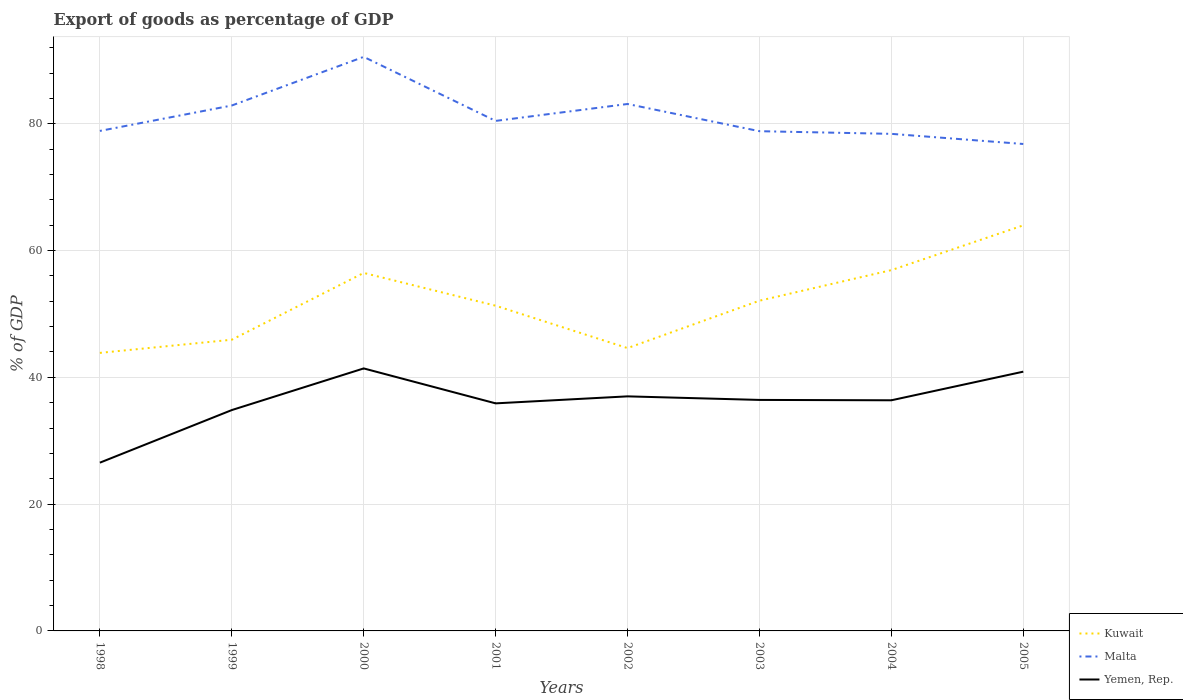Is the number of lines equal to the number of legend labels?
Give a very brief answer. Yes. Across all years, what is the maximum export of goods as percentage of GDP in Yemen, Rep.?
Your response must be concise. 26.54. In which year was the export of goods as percentage of GDP in Kuwait maximum?
Your response must be concise. 1998. What is the total export of goods as percentage of GDP in Malta in the graph?
Ensure brevity in your answer.  7.43. What is the difference between the highest and the second highest export of goods as percentage of GDP in Kuwait?
Provide a short and direct response. 20.12. How many lines are there?
Your answer should be very brief. 3. How many years are there in the graph?
Your answer should be very brief. 8. What is the difference between two consecutive major ticks on the Y-axis?
Provide a succinct answer. 20. Are the values on the major ticks of Y-axis written in scientific E-notation?
Give a very brief answer. No. Does the graph contain any zero values?
Provide a short and direct response. No. Does the graph contain grids?
Make the answer very short. Yes. Where does the legend appear in the graph?
Your answer should be very brief. Bottom right. How many legend labels are there?
Provide a succinct answer. 3. What is the title of the graph?
Make the answer very short. Export of goods as percentage of GDP. What is the label or title of the X-axis?
Your response must be concise. Years. What is the label or title of the Y-axis?
Your answer should be very brief. % of GDP. What is the % of GDP in Kuwait in 1998?
Ensure brevity in your answer.  43.86. What is the % of GDP of Malta in 1998?
Provide a succinct answer. 78.88. What is the % of GDP in Yemen, Rep. in 1998?
Give a very brief answer. 26.54. What is the % of GDP of Kuwait in 1999?
Provide a short and direct response. 45.94. What is the % of GDP in Malta in 1999?
Provide a succinct answer. 82.88. What is the % of GDP in Yemen, Rep. in 1999?
Give a very brief answer. 34.84. What is the % of GDP in Kuwait in 2000?
Your answer should be compact. 56.47. What is the % of GDP in Malta in 2000?
Give a very brief answer. 90.56. What is the % of GDP in Yemen, Rep. in 2000?
Make the answer very short. 41.41. What is the % of GDP of Kuwait in 2001?
Your answer should be very brief. 51.3. What is the % of GDP of Malta in 2001?
Give a very brief answer. 80.45. What is the % of GDP in Yemen, Rep. in 2001?
Give a very brief answer. 35.9. What is the % of GDP in Kuwait in 2002?
Your answer should be compact. 44.62. What is the % of GDP in Malta in 2002?
Your answer should be compact. 83.12. What is the % of GDP of Yemen, Rep. in 2002?
Make the answer very short. 37. What is the % of GDP of Kuwait in 2003?
Offer a very short reply. 52.09. What is the % of GDP of Malta in 2003?
Your answer should be very brief. 78.83. What is the % of GDP in Yemen, Rep. in 2003?
Offer a terse response. 36.44. What is the % of GDP in Kuwait in 2004?
Offer a terse response. 56.92. What is the % of GDP in Malta in 2004?
Provide a succinct answer. 78.41. What is the % of GDP of Yemen, Rep. in 2004?
Offer a terse response. 36.38. What is the % of GDP in Kuwait in 2005?
Keep it short and to the point. 63.98. What is the % of GDP of Malta in 2005?
Give a very brief answer. 76.81. What is the % of GDP of Yemen, Rep. in 2005?
Make the answer very short. 40.9. Across all years, what is the maximum % of GDP of Kuwait?
Offer a very short reply. 63.98. Across all years, what is the maximum % of GDP of Malta?
Provide a short and direct response. 90.56. Across all years, what is the maximum % of GDP in Yemen, Rep.?
Offer a terse response. 41.41. Across all years, what is the minimum % of GDP of Kuwait?
Give a very brief answer. 43.86. Across all years, what is the minimum % of GDP in Malta?
Offer a terse response. 76.81. Across all years, what is the minimum % of GDP in Yemen, Rep.?
Keep it short and to the point. 26.54. What is the total % of GDP of Kuwait in the graph?
Make the answer very short. 415.17. What is the total % of GDP in Malta in the graph?
Offer a terse response. 649.95. What is the total % of GDP in Yemen, Rep. in the graph?
Provide a short and direct response. 289.41. What is the difference between the % of GDP in Kuwait in 1998 and that in 1999?
Provide a short and direct response. -2.08. What is the difference between the % of GDP in Malta in 1998 and that in 1999?
Your answer should be compact. -4.01. What is the difference between the % of GDP of Yemen, Rep. in 1998 and that in 1999?
Provide a short and direct response. -8.3. What is the difference between the % of GDP in Kuwait in 1998 and that in 2000?
Keep it short and to the point. -12.61. What is the difference between the % of GDP of Malta in 1998 and that in 2000?
Provide a succinct answer. -11.68. What is the difference between the % of GDP in Yemen, Rep. in 1998 and that in 2000?
Offer a terse response. -14.87. What is the difference between the % of GDP of Kuwait in 1998 and that in 2001?
Make the answer very short. -7.44. What is the difference between the % of GDP of Malta in 1998 and that in 2001?
Provide a succinct answer. -1.58. What is the difference between the % of GDP in Yemen, Rep. in 1998 and that in 2001?
Provide a short and direct response. -9.35. What is the difference between the % of GDP of Kuwait in 1998 and that in 2002?
Give a very brief answer. -0.76. What is the difference between the % of GDP in Malta in 1998 and that in 2002?
Make the answer very short. -4.25. What is the difference between the % of GDP in Yemen, Rep. in 1998 and that in 2002?
Ensure brevity in your answer.  -10.46. What is the difference between the % of GDP of Kuwait in 1998 and that in 2003?
Make the answer very short. -8.23. What is the difference between the % of GDP of Malta in 1998 and that in 2003?
Your response must be concise. 0.04. What is the difference between the % of GDP in Yemen, Rep. in 1998 and that in 2003?
Offer a terse response. -9.9. What is the difference between the % of GDP of Kuwait in 1998 and that in 2004?
Keep it short and to the point. -13.06. What is the difference between the % of GDP in Malta in 1998 and that in 2004?
Ensure brevity in your answer.  0.46. What is the difference between the % of GDP of Yemen, Rep. in 1998 and that in 2004?
Keep it short and to the point. -9.84. What is the difference between the % of GDP in Kuwait in 1998 and that in 2005?
Ensure brevity in your answer.  -20.12. What is the difference between the % of GDP in Malta in 1998 and that in 2005?
Provide a succinct answer. 2.06. What is the difference between the % of GDP in Yemen, Rep. in 1998 and that in 2005?
Your answer should be compact. -14.35. What is the difference between the % of GDP of Kuwait in 1999 and that in 2000?
Your answer should be compact. -10.54. What is the difference between the % of GDP in Malta in 1999 and that in 2000?
Ensure brevity in your answer.  -7.67. What is the difference between the % of GDP in Yemen, Rep. in 1999 and that in 2000?
Your answer should be compact. -6.57. What is the difference between the % of GDP of Kuwait in 1999 and that in 2001?
Provide a short and direct response. -5.37. What is the difference between the % of GDP of Malta in 1999 and that in 2001?
Ensure brevity in your answer.  2.43. What is the difference between the % of GDP of Yemen, Rep. in 1999 and that in 2001?
Your answer should be very brief. -1.06. What is the difference between the % of GDP of Kuwait in 1999 and that in 2002?
Provide a succinct answer. 1.32. What is the difference between the % of GDP of Malta in 1999 and that in 2002?
Your answer should be very brief. -0.24. What is the difference between the % of GDP in Yemen, Rep. in 1999 and that in 2002?
Keep it short and to the point. -2.16. What is the difference between the % of GDP of Kuwait in 1999 and that in 2003?
Your answer should be very brief. -6.16. What is the difference between the % of GDP of Malta in 1999 and that in 2003?
Keep it short and to the point. 4.05. What is the difference between the % of GDP in Yemen, Rep. in 1999 and that in 2003?
Offer a very short reply. -1.6. What is the difference between the % of GDP of Kuwait in 1999 and that in 2004?
Offer a terse response. -10.98. What is the difference between the % of GDP of Malta in 1999 and that in 2004?
Give a very brief answer. 4.47. What is the difference between the % of GDP of Yemen, Rep. in 1999 and that in 2004?
Make the answer very short. -1.54. What is the difference between the % of GDP of Kuwait in 1999 and that in 2005?
Offer a terse response. -18.04. What is the difference between the % of GDP of Malta in 1999 and that in 2005?
Ensure brevity in your answer.  6.07. What is the difference between the % of GDP of Yemen, Rep. in 1999 and that in 2005?
Provide a succinct answer. -6.06. What is the difference between the % of GDP in Kuwait in 2000 and that in 2001?
Your answer should be very brief. 5.17. What is the difference between the % of GDP in Malta in 2000 and that in 2001?
Provide a succinct answer. 10.1. What is the difference between the % of GDP of Yemen, Rep. in 2000 and that in 2001?
Your response must be concise. 5.51. What is the difference between the % of GDP in Kuwait in 2000 and that in 2002?
Provide a succinct answer. 11.86. What is the difference between the % of GDP in Malta in 2000 and that in 2002?
Offer a very short reply. 7.43. What is the difference between the % of GDP of Yemen, Rep. in 2000 and that in 2002?
Make the answer very short. 4.41. What is the difference between the % of GDP in Kuwait in 2000 and that in 2003?
Your answer should be compact. 4.38. What is the difference between the % of GDP of Malta in 2000 and that in 2003?
Give a very brief answer. 11.73. What is the difference between the % of GDP in Yemen, Rep. in 2000 and that in 2003?
Ensure brevity in your answer.  4.97. What is the difference between the % of GDP in Kuwait in 2000 and that in 2004?
Offer a terse response. -0.44. What is the difference between the % of GDP of Malta in 2000 and that in 2004?
Ensure brevity in your answer.  12.14. What is the difference between the % of GDP in Yemen, Rep. in 2000 and that in 2004?
Keep it short and to the point. 5.03. What is the difference between the % of GDP in Kuwait in 2000 and that in 2005?
Make the answer very short. -7.5. What is the difference between the % of GDP in Malta in 2000 and that in 2005?
Your answer should be very brief. 13.74. What is the difference between the % of GDP in Yemen, Rep. in 2000 and that in 2005?
Make the answer very short. 0.51. What is the difference between the % of GDP of Kuwait in 2001 and that in 2002?
Provide a succinct answer. 6.69. What is the difference between the % of GDP of Malta in 2001 and that in 2002?
Your answer should be compact. -2.67. What is the difference between the % of GDP in Yemen, Rep. in 2001 and that in 2002?
Provide a short and direct response. -1.1. What is the difference between the % of GDP in Kuwait in 2001 and that in 2003?
Offer a terse response. -0.79. What is the difference between the % of GDP of Malta in 2001 and that in 2003?
Provide a succinct answer. 1.62. What is the difference between the % of GDP of Yemen, Rep. in 2001 and that in 2003?
Give a very brief answer. -0.54. What is the difference between the % of GDP in Kuwait in 2001 and that in 2004?
Keep it short and to the point. -5.61. What is the difference between the % of GDP of Malta in 2001 and that in 2004?
Your response must be concise. 2.04. What is the difference between the % of GDP of Yemen, Rep. in 2001 and that in 2004?
Make the answer very short. -0.49. What is the difference between the % of GDP of Kuwait in 2001 and that in 2005?
Offer a terse response. -12.67. What is the difference between the % of GDP of Malta in 2001 and that in 2005?
Your response must be concise. 3.64. What is the difference between the % of GDP of Yemen, Rep. in 2001 and that in 2005?
Keep it short and to the point. -5. What is the difference between the % of GDP of Kuwait in 2002 and that in 2003?
Offer a very short reply. -7.48. What is the difference between the % of GDP of Malta in 2002 and that in 2003?
Ensure brevity in your answer.  4.29. What is the difference between the % of GDP of Yemen, Rep. in 2002 and that in 2003?
Offer a very short reply. 0.56. What is the difference between the % of GDP in Kuwait in 2002 and that in 2004?
Ensure brevity in your answer.  -12.3. What is the difference between the % of GDP of Malta in 2002 and that in 2004?
Keep it short and to the point. 4.71. What is the difference between the % of GDP in Yemen, Rep. in 2002 and that in 2004?
Keep it short and to the point. 0.62. What is the difference between the % of GDP of Kuwait in 2002 and that in 2005?
Ensure brevity in your answer.  -19.36. What is the difference between the % of GDP in Malta in 2002 and that in 2005?
Make the answer very short. 6.31. What is the difference between the % of GDP of Yemen, Rep. in 2002 and that in 2005?
Ensure brevity in your answer.  -3.9. What is the difference between the % of GDP in Kuwait in 2003 and that in 2004?
Your answer should be compact. -4.82. What is the difference between the % of GDP in Malta in 2003 and that in 2004?
Your response must be concise. 0.42. What is the difference between the % of GDP in Yemen, Rep. in 2003 and that in 2004?
Your answer should be very brief. 0.06. What is the difference between the % of GDP in Kuwait in 2003 and that in 2005?
Your response must be concise. -11.88. What is the difference between the % of GDP in Malta in 2003 and that in 2005?
Your response must be concise. 2.02. What is the difference between the % of GDP of Yemen, Rep. in 2003 and that in 2005?
Offer a terse response. -4.46. What is the difference between the % of GDP in Kuwait in 2004 and that in 2005?
Offer a terse response. -7.06. What is the difference between the % of GDP in Malta in 2004 and that in 2005?
Your response must be concise. 1.6. What is the difference between the % of GDP in Yemen, Rep. in 2004 and that in 2005?
Offer a very short reply. -4.51. What is the difference between the % of GDP in Kuwait in 1998 and the % of GDP in Malta in 1999?
Your answer should be compact. -39.03. What is the difference between the % of GDP in Kuwait in 1998 and the % of GDP in Yemen, Rep. in 1999?
Offer a terse response. 9.02. What is the difference between the % of GDP of Malta in 1998 and the % of GDP of Yemen, Rep. in 1999?
Offer a terse response. 44.04. What is the difference between the % of GDP of Kuwait in 1998 and the % of GDP of Malta in 2000?
Provide a short and direct response. -46.7. What is the difference between the % of GDP of Kuwait in 1998 and the % of GDP of Yemen, Rep. in 2000?
Your answer should be compact. 2.45. What is the difference between the % of GDP of Malta in 1998 and the % of GDP of Yemen, Rep. in 2000?
Your answer should be very brief. 37.47. What is the difference between the % of GDP in Kuwait in 1998 and the % of GDP in Malta in 2001?
Make the answer very short. -36.6. What is the difference between the % of GDP in Kuwait in 1998 and the % of GDP in Yemen, Rep. in 2001?
Make the answer very short. 7.96. What is the difference between the % of GDP of Malta in 1998 and the % of GDP of Yemen, Rep. in 2001?
Your response must be concise. 42.98. What is the difference between the % of GDP of Kuwait in 1998 and the % of GDP of Malta in 2002?
Keep it short and to the point. -39.26. What is the difference between the % of GDP in Kuwait in 1998 and the % of GDP in Yemen, Rep. in 2002?
Offer a very short reply. 6.86. What is the difference between the % of GDP of Malta in 1998 and the % of GDP of Yemen, Rep. in 2002?
Offer a terse response. 41.87. What is the difference between the % of GDP in Kuwait in 1998 and the % of GDP in Malta in 2003?
Your response must be concise. -34.97. What is the difference between the % of GDP of Kuwait in 1998 and the % of GDP of Yemen, Rep. in 2003?
Provide a succinct answer. 7.42. What is the difference between the % of GDP of Malta in 1998 and the % of GDP of Yemen, Rep. in 2003?
Give a very brief answer. 42.44. What is the difference between the % of GDP of Kuwait in 1998 and the % of GDP of Malta in 2004?
Offer a very short reply. -34.55. What is the difference between the % of GDP of Kuwait in 1998 and the % of GDP of Yemen, Rep. in 2004?
Offer a terse response. 7.48. What is the difference between the % of GDP in Malta in 1998 and the % of GDP in Yemen, Rep. in 2004?
Your answer should be compact. 42.49. What is the difference between the % of GDP in Kuwait in 1998 and the % of GDP in Malta in 2005?
Give a very brief answer. -32.95. What is the difference between the % of GDP of Kuwait in 1998 and the % of GDP of Yemen, Rep. in 2005?
Offer a terse response. 2.96. What is the difference between the % of GDP in Malta in 1998 and the % of GDP in Yemen, Rep. in 2005?
Ensure brevity in your answer.  37.98. What is the difference between the % of GDP in Kuwait in 1999 and the % of GDP in Malta in 2000?
Your answer should be compact. -44.62. What is the difference between the % of GDP of Kuwait in 1999 and the % of GDP of Yemen, Rep. in 2000?
Provide a short and direct response. 4.53. What is the difference between the % of GDP in Malta in 1999 and the % of GDP in Yemen, Rep. in 2000?
Offer a terse response. 41.48. What is the difference between the % of GDP in Kuwait in 1999 and the % of GDP in Malta in 2001?
Your response must be concise. -34.52. What is the difference between the % of GDP of Kuwait in 1999 and the % of GDP of Yemen, Rep. in 2001?
Provide a succinct answer. 10.04. What is the difference between the % of GDP of Malta in 1999 and the % of GDP of Yemen, Rep. in 2001?
Ensure brevity in your answer.  46.99. What is the difference between the % of GDP of Kuwait in 1999 and the % of GDP of Malta in 2002?
Your response must be concise. -37.19. What is the difference between the % of GDP of Kuwait in 1999 and the % of GDP of Yemen, Rep. in 2002?
Ensure brevity in your answer.  8.94. What is the difference between the % of GDP of Malta in 1999 and the % of GDP of Yemen, Rep. in 2002?
Offer a very short reply. 45.88. What is the difference between the % of GDP in Kuwait in 1999 and the % of GDP in Malta in 2003?
Give a very brief answer. -32.89. What is the difference between the % of GDP in Kuwait in 1999 and the % of GDP in Yemen, Rep. in 2003?
Your answer should be compact. 9.5. What is the difference between the % of GDP of Malta in 1999 and the % of GDP of Yemen, Rep. in 2003?
Your answer should be compact. 46.45. What is the difference between the % of GDP in Kuwait in 1999 and the % of GDP in Malta in 2004?
Make the answer very short. -32.48. What is the difference between the % of GDP in Kuwait in 1999 and the % of GDP in Yemen, Rep. in 2004?
Give a very brief answer. 9.55. What is the difference between the % of GDP in Malta in 1999 and the % of GDP in Yemen, Rep. in 2004?
Offer a very short reply. 46.5. What is the difference between the % of GDP in Kuwait in 1999 and the % of GDP in Malta in 2005?
Make the answer very short. -30.88. What is the difference between the % of GDP in Kuwait in 1999 and the % of GDP in Yemen, Rep. in 2005?
Provide a short and direct response. 5.04. What is the difference between the % of GDP in Malta in 1999 and the % of GDP in Yemen, Rep. in 2005?
Offer a terse response. 41.99. What is the difference between the % of GDP in Kuwait in 2000 and the % of GDP in Malta in 2001?
Your response must be concise. -23.98. What is the difference between the % of GDP in Kuwait in 2000 and the % of GDP in Yemen, Rep. in 2001?
Give a very brief answer. 20.58. What is the difference between the % of GDP in Malta in 2000 and the % of GDP in Yemen, Rep. in 2001?
Give a very brief answer. 54.66. What is the difference between the % of GDP in Kuwait in 2000 and the % of GDP in Malta in 2002?
Keep it short and to the point. -26.65. What is the difference between the % of GDP of Kuwait in 2000 and the % of GDP of Yemen, Rep. in 2002?
Your response must be concise. 19.47. What is the difference between the % of GDP in Malta in 2000 and the % of GDP in Yemen, Rep. in 2002?
Offer a terse response. 53.56. What is the difference between the % of GDP in Kuwait in 2000 and the % of GDP in Malta in 2003?
Offer a terse response. -22.36. What is the difference between the % of GDP of Kuwait in 2000 and the % of GDP of Yemen, Rep. in 2003?
Your answer should be compact. 20.03. What is the difference between the % of GDP of Malta in 2000 and the % of GDP of Yemen, Rep. in 2003?
Your answer should be compact. 54.12. What is the difference between the % of GDP in Kuwait in 2000 and the % of GDP in Malta in 2004?
Provide a short and direct response. -21.94. What is the difference between the % of GDP in Kuwait in 2000 and the % of GDP in Yemen, Rep. in 2004?
Offer a very short reply. 20.09. What is the difference between the % of GDP in Malta in 2000 and the % of GDP in Yemen, Rep. in 2004?
Provide a succinct answer. 54.17. What is the difference between the % of GDP in Kuwait in 2000 and the % of GDP in Malta in 2005?
Ensure brevity in your answer.  -20.34. What is the difference between the % of GDP in Kuwait in 2000 and the % of GDP in Yemen, Rep. in 2005?
Your answer should be compact. 15.58. What is the difference between the % of GDP of Malta in 2000 and the % of GDP of Yemen, Rep. in 2005?
Provide a short and direct response. 49.66. What is the difference between the % of GDP in Kuwait in 2001 and the % of GDP in Malta in 2002?
Offer a terse response. -31.82. What is the difference between the % of GDP of Kuwait in 2001 and the % of GDP of Yemen, Rep. in 2002?
Make the answer very short. 14.3. What is the difference between the % of GDP of Malta in 2001 and the % of GDP of Yemen, Rep. in 2002?
Your answer should be very brief. 43.45. What is the difference between the % of GDP in Kuwait in 2001 and the % of GDP in Malta in 2003?
Your answer should be compact. -27.53. What is the difference between the % of GDP in Kuwait in 2001 and the % of GDP in Yemen, Rep. in 2003?
Keep it short and to the point. 14.86. What is the difference between the % of GDP in Malta in 2001 and the % of GDP in Yemen, Rep. in 2003?
Your response must be concise. 44.02. What is the difference between the % of GDP of Kuwait in 2001 and the % of GDP of Malta in 2004?
Provide a succinct answer. -27.11. What is the difference between the % of GDP in Kuwait in 2001 and the % of GDP in Yemen, Rep. in 2004?
Provide a short and direct response. 14.92. What is the difference between the % of GDP of Malta in 2001 and the % of GDP of Yemen, Rep. in 2004?
Offer a very short reply. 44.07. What is the difference between the % of GDP in Kuwait in 2001 and the % of GDP in Malta in 2005?
Make the answer very short. -25.51. What is the difference between the % of GDP of Kuwait in 2001 and the % of GDP of Yemen, Rep. in 2005?
Give a very brief answer. 10.41. What is the difference between the % of GDP of Malta in 2001 and the % of GDP of Yemen, Rep. in 2005?
Provide a short and direct response. 39.56. What is the difference between the % of GDP of Kuwait in 2002 and the % of GDP of Malta in 2003?
Provide a short and direct response. -34.22. What is the difference between the % of GDP of Kuwait in 2002 and the % of GDP of Yemen, Rep. in 2003?
Give a very brief answer. 8.18. What is the difference between the % of GDP of Malta in 2002 and the % of GDP of Yemen, Rep. in 2003?
Give a very brief answer. 46.68. What is the difference between the % of GDP of Kuwait in 2002 and the % of GDP of Malta in 2004?
Offer a terse response. -33.8. What is the difference between the % of GDP of Kuwait in 2002 and the % of GDP of Yemen, Rep. in 2004?
Offer a very short reply. 8.23. What is the difference between the % of GDP in Malta in 2002 and the % of GDP in Yemen, Rep. in 2004?
Ensure brevity in your answer.  46.74. What is the difference between the % of GDP of Kuwait in 2002 and the % of GDP of Malta in 2005?
Your response must be concise. -32.2. What is the difference between the % of GDP of Kuwait in 2002 and the % of GDP of Yemen, Rep. in 2005?
Ensure brevity in your answer.  3.72. What is the difference between the % of GDP in Malta in 2002 and the % of GDP in Yemen, Rep. in 2005?
Provide a succinct answer. 42.23. What is the difference between the % of GDP in Kuwait in 2003 and the % of GDP in Malta in 2004?
Offer a very short reply. -26.32. What is the difference between the % of GDP in Kuwait in 2003 and the % of GDP in Yemen, Rep. in 2004?
Your response must be concise. 15.71. What is the difference between the % of GDP of Malta in 2003 and the % of GDP of Yemen, Rep. in 2004?
Provide a short and direct response. 42.45. What is the difference between the % of GDP of Kuwait in 2003 and the % of GDP of Malta in 2005?
Provide a short and direct response. -24.72. What is the difference between the % of GDP in Kuwait in 2003 and the % of GDP in Yemen, Rep. in 2005?
Make the answer very short. 11.2. What is the difference between the % of GDP of Malta in 2003 and the % of GDP of Yemen, Rep. in 2005?
Provide a short and direct response. 37.93. What is the difference between the % of GDP in Kuwait in 2004 and the % of GDP in Malta in 2005?
Give a very brief answer. -19.9. What is the difference between the % of GDP in Kuwait in 2004 and the % of GDP in Yemen, Rep. in 2005?
Your response must be concise. 16.02. What is the difference between the % of GDP in Malta in 2004 and the % of GDP in Yemen, Rep. in 2005?
Ensure brevity in your answer.  37.52. What is the average % of GDP in Kuwait per year?
Ensure brevity in your answer.  51.9. What is the average % of GDP in Malta per year?
Provide a succinct answer. 81.24. What is the average % of GDP of Yemen, Rep. per year?
Give a very brief answer. 36.18. In the year 1998, what is the difference between the % of GDP of Kuwait and % of GDP of Malta?
Provide a short and direct response. -35.02. In the year 1998, what is the difference between the % of GDP of Kuwait and % of GDP of Yemen, Rep.?
Offer a very short reply. 17.32. In the year 1998, what is the difference between the % of GDP of Malta and % of GDP of Yemen, Rep.?
Make the answer very short. 52.33. In the year 1999, what is the difference between the % of GDP in Kuwait and % of GDP in Malta?
Provide a succinct answer. -36.95. In the year 1999, what is the difference between the % of GDP of Kuwait and % of GDP of Yemen, Rep.?
Offer a terse response. 11.1. In the year 1999, what is the difference between the % of GDP in Malta and % of GDP in Yemen, Rep.?
Give a very brief answer. 48.05. In the year 2000, what is the difference between the % of GDP of Kuwait and % of GDP of Malta?
Ensure brevity in your answer.  -34.08. In the year 2000, what is the difference between the % of GDP in Kuwait and % of GDP in Yemen, Rep.?
Give a very brief answer. 15.06. In the year 2000, what is the difference between the % of GDP of Malta and % of GDP of Yemen, Rep.?
Offer a very short reply. 49.15. In the year 2001, what is the difference between the % of GDP in Kuwait and % of GDP in Malta?
Offer a very short reply. -29.15. In the year 2001, what is the difference between the % of GDP of Kuwait and % of GDP of Yemen, Rep.?
Your answer should be compact. 15.41. In the year 2001, what is the difference between the % of GDP in Malta and % of GDP in Yemen, Rep.?
Your answer should be very brief. 44.56. In the year 2002, what is the difference between the % of GDP in Kuwait and % of GDP in Malta?
Keep it short and to the point. -38.51. In the year 2002, what is the difference between the % of GDP of Kuwait and % of GDP of Yemen, Rep.?
Ensure brevity in your answer.  7.61. In the year 2002, what is the difference between the % of GDP in Malta and % of GDP in Yemen, Rep.?
Ensure brevity in your answer.  46.12. In the year 2003, what is the difference between the % of GDP of Kuwait and % of GDP of Malta?
Provide a short and direct response. -26.74. In the year 2003, what is the difference between the % of GDP of Kuwait and % of GDP of Yemen, Rep.?
Your answer should be compact. 15.65. In the year 2003, what is the difference between the % of GDP in Malta and % of GDP in Yemen, Rep.?
Offer a terse response. 42.39. In the year 2004, what is the difference between the % of GDP of Kuwait and % of GDP of Malta?
Give a very brief answer. -21.5. In the year 2004, what is the difference between the % of GDP in Kuwait and % of GDP in Yemen, Rep.?
Your answer should be very brief. 20.53. In the year 2004, what is the difference between the % of GDP in Malta and % of GDP in Yemen, Rep.?
Ensure brevity in your answer.  42.03. In the year 2005, what is the difference between the % of GDP of Kuwait and % of GDP of Malta?
Your answer should be very brief. -12.84. In the year 2005, what is the difference between the % of GDP of Kuwait and % of GDP of Yemen, Rep.?
Provide a short and direct response. 23.08. In the year 2005, what is the difference between the % of GDP of Malta and % of GDP of Yemen, Rep.?
Provide a short and direct response. 35.92. What is the ratio of the % of GDP of Kuwait in 1998 to that in 1999?
Provide a short and direct response. 0.95. What is the ratio of the % of GDP in Malta in 1998 to that in 1999?
Make the answer very short. 0.95. What is the ratio of the % of GDP in Yemen, Rep. in 1998 to that in 1999?
Make the answer very short. 0.76. What is the ratio of the % of GDP in Kuwait in 1998 to that in 2000?
Provide a succinct answer. 0.78. What is the ratio of the % of GDP of Malta in 1998 to that in 2000?
Your answer should be compact. 0.87. What is the ratio of the % of GDP in Yemen, Rep. in 1998 to that in 2000?
Your answer should be compact. 0.64. What is the ratio of the % of GDP of Kuwait in 1998 to that in 2001?
Offer a terse response. 0.85. What is the ratio of the % of GDP of Malta in 1998 to that in 2001?
Your response must be concise. 0.98. What is the ratio of the % of GDP of Yemen, Rep. in 1998 to that in 2001?
Provide a short and direct response. 0.74. What is the ratio of the % of GDP of Malta in 1998 to that in 2002?
Make the answer very short. 0.95. What is the ratio of the % of GDP in Yemen, Rep. in 1998 to that in 2002?
Offer a very short reply. 0.72. What is the ratio of the % of GDP in Kuwait in 1998 to that in 2003?
Provide a succinct answer. 0.84. What is the ratio of the % of GDP in Malta in 1998 to that in 2003?
Your response must be concise. 1. What is the ratio of the % of GDP in Yemen, Rep. in 1998 to that in 2003?
Your answer should be compact. 0.73. What is the ratio of the % of GDP of Kuwait in 1998 to that in 2004?
Your answer should be very brief. 0.77. What is the ratio of the % of GDP in Malta in 1998 to that in 2004?
Your answer should be compact. 1.01. What is the ratio of the % of GDP of Yemen, Rep. in 1998 to that in 2004?
Provide a short and direct response. 0.73. What is the ratio of the % of GDP in Kuwait in 1998 to that in 2005?
Your response must be concise. 0.69. What is the ratio of the % of GDP of Malta in 1998 to that in 2005?
Provide a short and direct response. 1.03. What is the ratio of the % of GDP in Yemen, Rep. in 1998 to that in 2005?
Ensure brevity in your answer.  0.65. What is the ratio of the % of GDP of Kuwait in 1999 to that in 2000?
Ensure brevity in your answer.  0.81. What is the ratio of the % of GDP of Malta in 1999 to that in 2000?
Your response must be concise. 0.92. What is the ratio of the % of GDP in Yemen, Rep. in 1999 to that in 2000?
Provide a short and direct response. 0.84. What is the ratio of the % of GDP in Kuwait in 1999 to that in 2001?
Your response must be concise. 0.9. What is the ratio of the % of GDP in Malta in 1999 to that in 2001?
Your answer should be very brief. 1.03. What is the ratio of the % of GDP of Yemen, Rep. in 1999 to that in 2001?
Keep it short and to the point. 0.97. What is the ratio of the % of GDP of Kuwait in 1999 to that in 2002?
Provide a succinct answer. 1.03. What is the ratio of the % of GDP of Yemen, Rep. in 1999 to that in 2002?
Keep it short and to the point. 0.94. What is the ratio of the % of GDP of Kuwait in 1999 to that in 2003?
Provide a succinct answer. 0.88. What is the ratio of the % of GDP of Malta in 1999 to that in 2003?
Offer a very short reply. 1.05. What is the ratio of the % of GDP in Yemen, Rep. in 1999 to that in 2003?
Your response must be concise. 0.96. What is the ratio of the % of GDP in Kuwait in 1999 to that in 2004?
Keep it short and to the point. 0.81. What is the ratio of the % of GDP in Malta in 1999 to that in 2004?
Your answer should be very brief. 1.06. What is the ratio of the % of GDP of Yemen, Rep. in 1999 to that in 2004?
Your answer should be very brief. 0.96. What is the ratio of the % of GDP of Kuwait in 1999 to that in 2005?
Offer a terse response. 0.72. What is the ratio of the % of GDP in Malta in 1999 to that in 2005?
Provide a succinct answer. 1.08. What is the ratio of the % of GDP in Yemen, Rep. in 1999 to that in 2005?
Offer a terse response. 0.85. What is the ratio of the % of GDP in Kuwait in 2000 to that in 2001?
Offer a very short reply. 1.1. What is the ratio of the % of GDP of Malta in 2000 to that in 2001?
Offer a terse response. 1.13. What is the ratio of the % of GDP in Yemen, Rep. in 2000 to that in 2001?
Make the answer very short. 1.15. What is the ratio of the % of GDP of Kuwait in 2000 to that in 2002?
Provide a short and direct response. 1.27. What is the ratio of the % of GDP in Malta in 2000 to that in 2002?
Your response must be concise. 1.09. What is the ratio of the % of GDP in Yemen, Rep. in 2000 to that in 2002?
Ensure brevity in your answer.  1.12. What is the ratio of the % of GDP of Kuwait in 2000 to that in 2003?
Offer a terse response. 1.08. What is the ratio of the % of GDP of Malta in 2000 to that in 2003?
Your answer should be very brief. 1.15. What is the ratio of the % of GDP in Yemen, Rep. in 2000 to that in 2003?
Keep it short and to the point. 1.14. What is the ratio of the % of GDP of Kuwait in 2000 to that in 2004?
Give a very brief answer. 0.99. What is the ratio of the % of GDP in Malta in 2000 to that in 2004?
Your response must be concise. 1.15. What is the ratio of the % of GDP of Yemen, Rep. in 2000 to that in 2004?
Your answer should be compact. 1.14. What is the ratio of the % of GDP in Kuwait in 2000 to that in 2005?
Your answer should be very brief. 0.88. What is the ratio of the % of GDP of Malta in 2000 to that in 2005?
Your response must be concise. 1.18. What is the ratio of the % of GDP of Yemen, Rep. in 2000 to that in 2005?
Give a very brief answer. 1.01. What is the ratio of the % of GDP of Kuwait in 2001 to that in 2002?
Offer a very short reply. 1.15. What is the ratio of the % of GDP in Malta in 2001 to that in 2002?
Make the answer very short. 0.97. What is the ratio of the % of GDP of Yemen, Rep. in 2001 to that in 2002?
Ensure brevity in your answer.  0.97. What is the ratio of the % of GDP in Kuwait in 2001 to that in 2003?
Make the answer very short. 0.98. What is the ratio of the % of GDP in Malta in 2001 to that in 2003?
Provide a succinct answer. 1.02. What is the ratio of the % of GDP of Yemen, Rep. in 2001 to that in 2003?
Make the answer very short. 0.99. What is the ratio of the % of GDP of Kuwait in 2001 to that in 2004?
Your answer should be very brief. 0.9. What is the ratio of the % of GDP in Malta in 2001 to that in 2004?
Keep it short and to the point. 1.03. What is the ratio of the % of GDP of Yemen, Rep. in 2001 to that in 2004?
Your answer should be very brief. 0.99. What is the ratio of the % of GDP of Kuwait in 2001 to that in 2005?
Your answer should be very brief. 0.8. What is the ratio of the % of GDP in Malta in 2001 to that in 2005?
Offer a terse response. 1.05. What is the ratio of the % of GDP of Yemen, Rep. in 2001 to that in 2005?
Make the answer very short. 0.88. What is the ratio of the % of GDP of Kuwait in 2002 to that in 2003?
Provide a short and direct response. 0.86. What is the ratio of the % of GDP of Malta in 2002 to that in 2003?
Provide a succinct answer. 1.05. What is the ratio of the % of GDP in Yemen, Rep. in 2002 to that in 2003?
Provide a succinct answer. 1.02. What is the ratio of the % of GDP of Kuwait in 2002 to that in 2004?
Provide a succinct answer. 0.78. What is the ratio of the % of GDP in Malta in 2002 to that in 2004?
Keep it short and to the point. 1.06. What is the ratio of the % of GDP of Yemen, Rep. in 2002 to that in 2004?
Offer a terse response. 1.02. What is the ratio of the % of GDP of Kuwait in 2002 to that in 2005?
Your response must be concise. 0.7. What is the ratio of the % of GDP in Malta in 2002 to that in 2005?
Offer a very short reply. 1.08. What is the ratio of the % of GDP of Yemen, Rep. in 2002 to that in 2005?
Keep it short and to the point. 0.9. What is the ratio of the % of GDP in Kuwait in 2003 to that in 2004?
Give a very brief answer. 0.92. What is the ratio of the % of GDP in Malta in 2003 to that in 2004?
Your response must be concise. 1.01. What is the ratio of the % of GDP in Yemen, Rep. in 2003 to that in 2004?
Your answer should be very brief. 1. What is the ratio of the % of GDP of Kuwait in 2003 to that in 2005?
Make the answer very short. 0.81. What is the ratio of the % of GDP of Malta in 2003 to that in 2005?
Make the answer very short. 1.03. What is the ratio of the % of GDP in Yemen, Rep. in 2003 to that in 2005?
Your answer should be very brief. 0.89. What is the ratio of the % of GDP in Kuwait in 2004 to that in 2005?
Your answer should be very brief. 0.89. What is the ratio of the % of GDP in Malta in 2004 to that in 2005?
Your response must be concise. 1.02. What is the ratio of the % of GDP in Yemen, Rep. in 2004 to that in 2005?
Provide a succinct answer. 0.89. What is the difference between the highest and the second highest % of GDP of Kuwait?
Provide a succinct answer. 7.06. What is the difference between the highest and the second highest % of GDP of Malta?
Your answer should be compact. 7.43. What is the difference between the highest and the second highest % of GDP of Yemen, Rep.?
Provide a succinct answer. 0.51. What is the difference between the highest and the lowest % of GDP of Kuwait?
Your answer should be compact. 20.12. What is the difference between the highest and the lowest % of GDP in Malta?
Ensure brevity in your answer.  13.74. What is the difference between the highest and the lowest % of GDP of Yemen, Rep.?
Offer a very short reply. 14.87. 